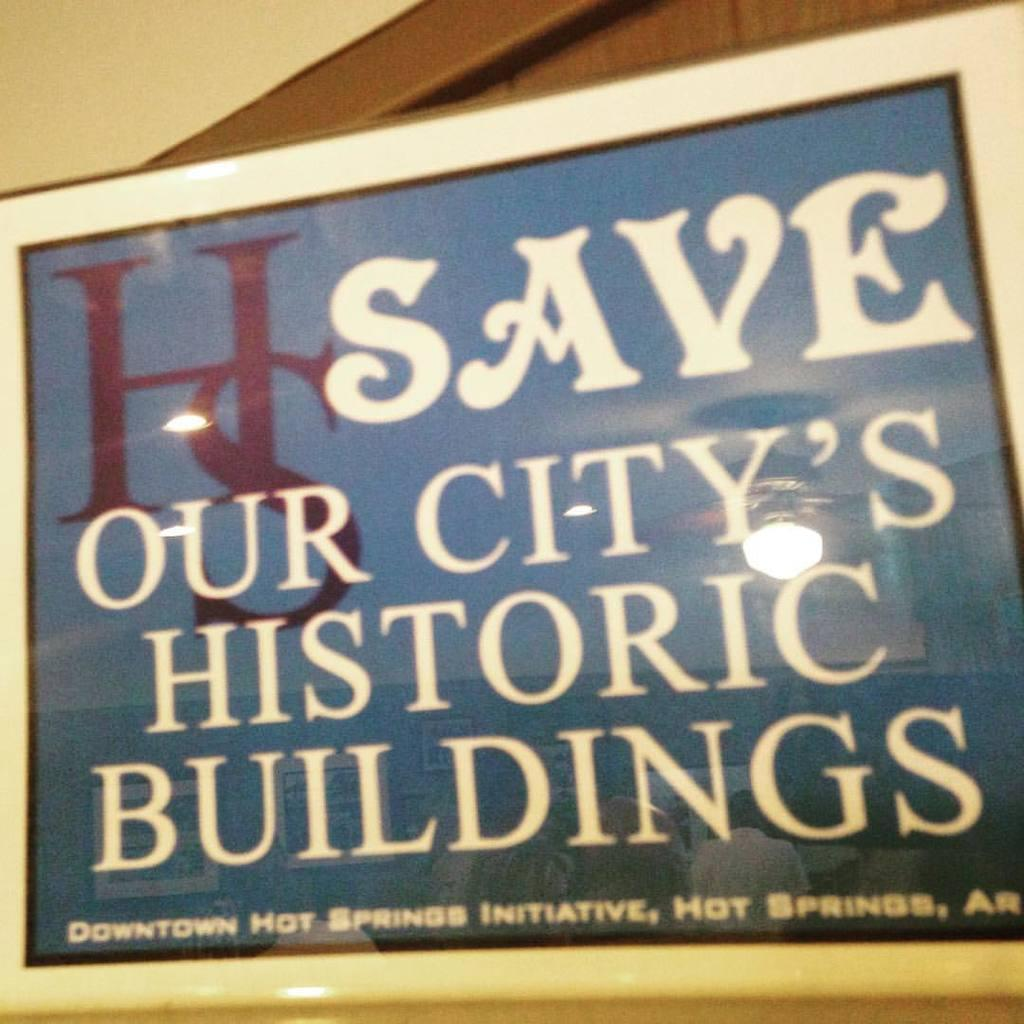<image>
Summarize the visual content of the image. An advertisement for saving historic buildings in Arkansas 